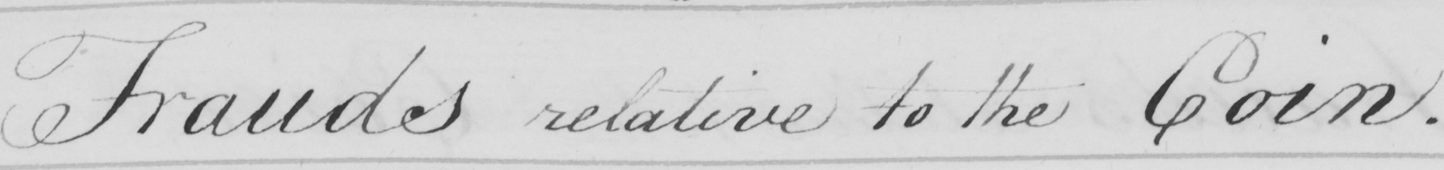What does this handwritten line say? Frauds relative to the Coin . 